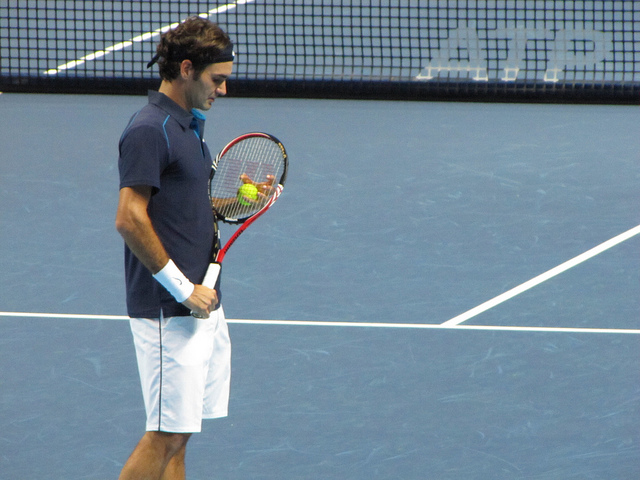Please extract the text content from this image. ATP 